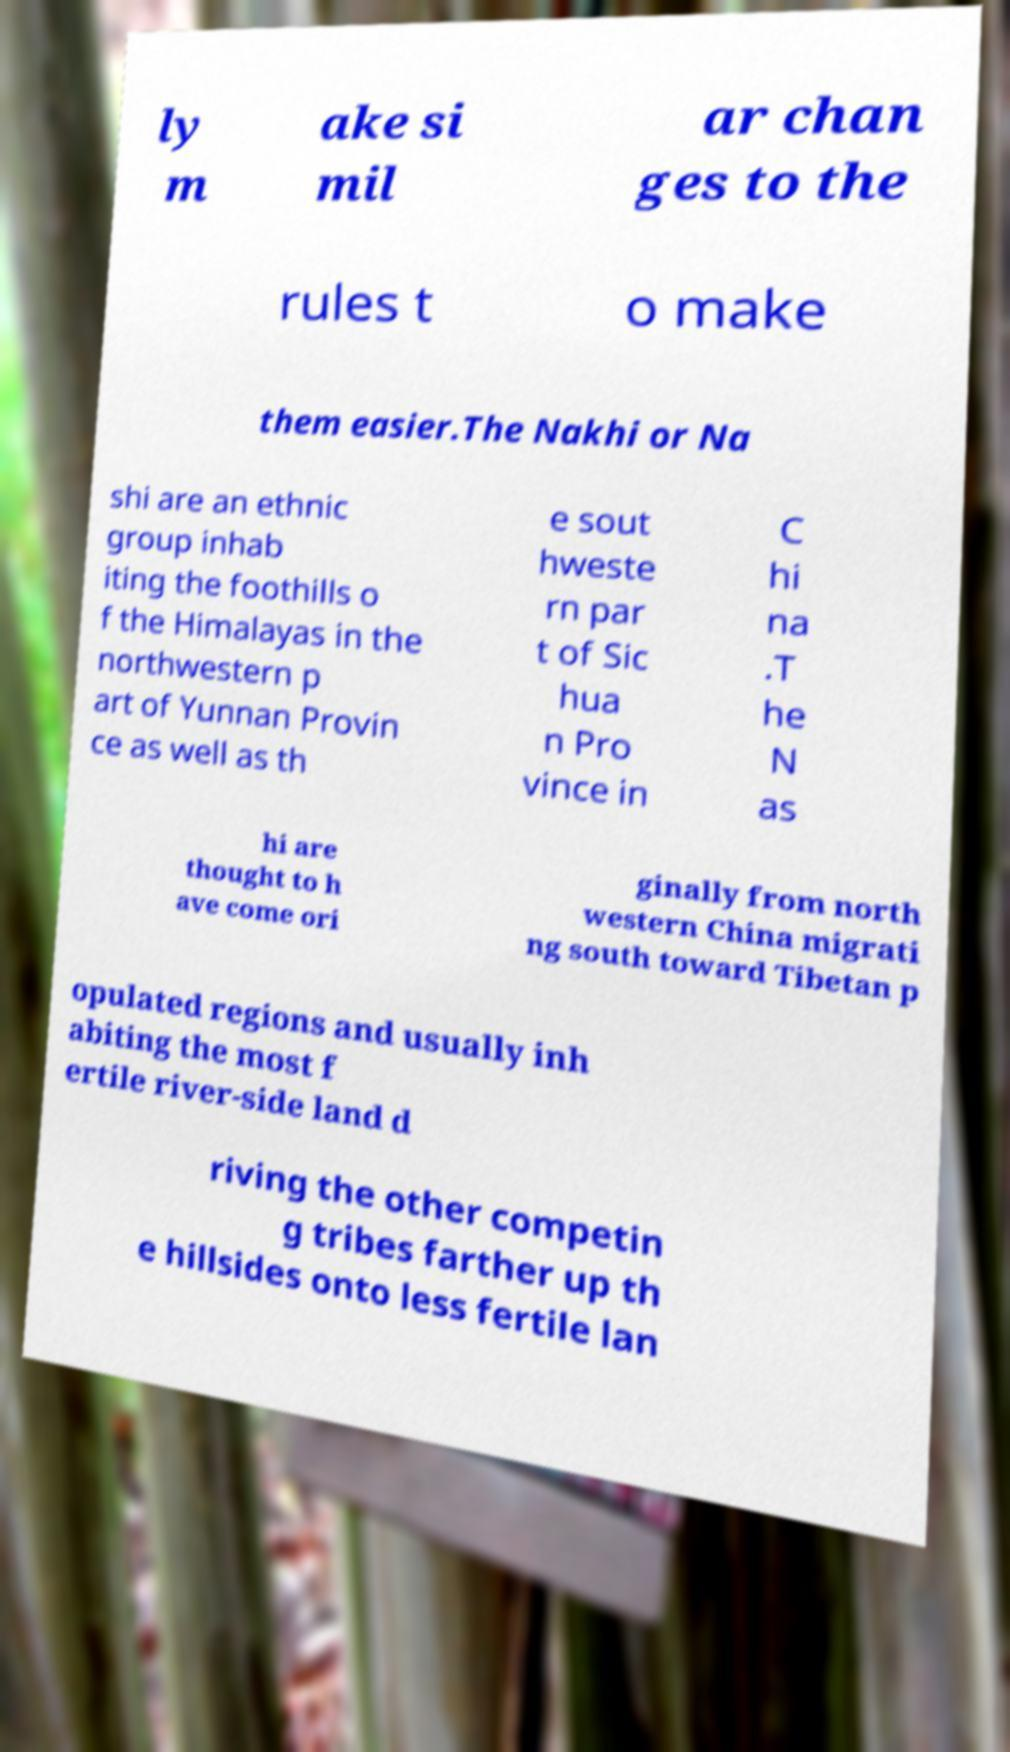Please read and relay the text visible in this image. What does it say? ly m ake si mil ar chan ges to the rules t o make them easier.The Nakhi or Na shi are an ethnic group inhab iting the foothills o f the Himalayas in the northwestern p art of Yunnan Provin ce as well as th e sout hweste rn par t of Sic hua n Pro vince in C hi na .T he N as hi are thought to h ave come ori ginally from north western China migrati ng south toward Tibetan p opulated regions and usually inh abiting the most f ertile river-side land d riving the other competin g tribes farther up th e hillsides onto less fertile lan 